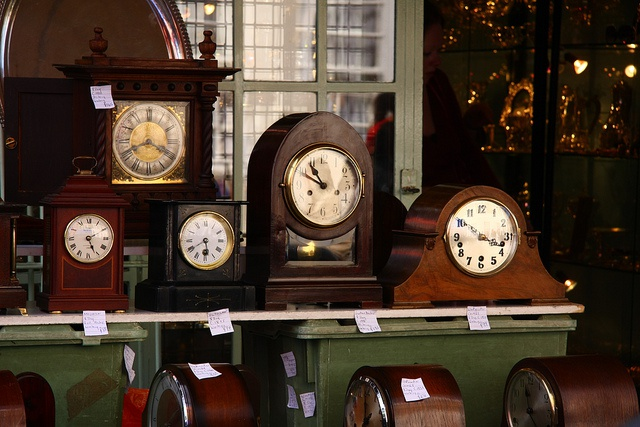Describe the objects in this image and their specific colors. I can see clock in black, maroon, and gray tones, clock in black, maroon, and brown tones, clock in black, tan, and gray tones, clock in black, maroon, gray, and lavender tones, and clock in black, tan, and beige tones in this image. 